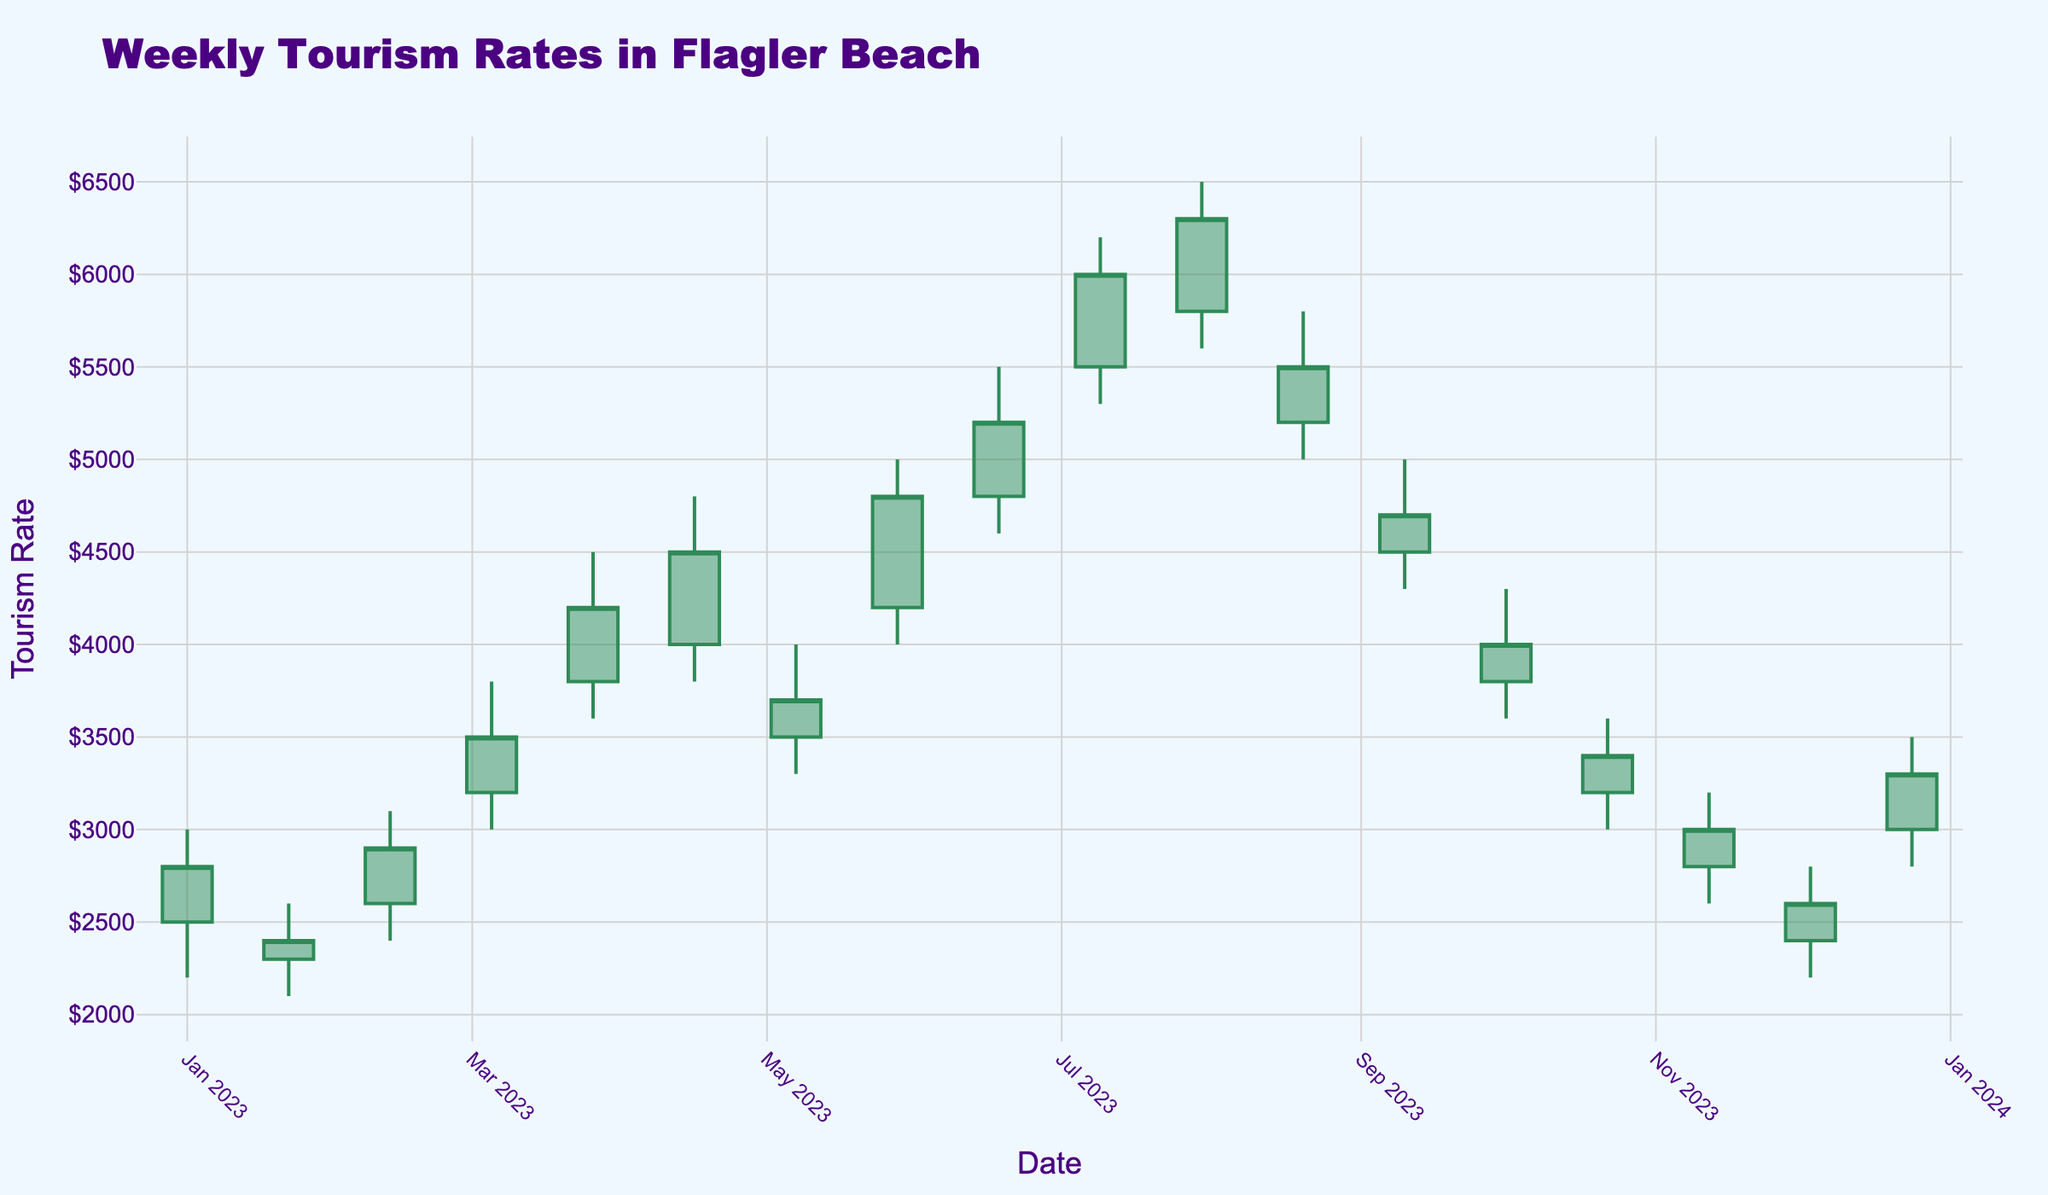What is the title of the chart? The title is usually located at the top of the chart. For the given chart, the title states "Weekly Tourism Rates in Flagler Beach."
Answer: Weekly Tourism Rates in Flagler Beach Which week had the highest tourism rate close? To find the week with the highest tourism rate at close, look for the highest point on the 'Close' line in the chart. In this case, it is the week "Jul 30-Aug 5" with a close of 6300.
Answer: Jul 30-Aug 5 What is the color of the lines for increasing tourism rates? The lines for increasing tourism rates are represented in a color. Here, the color mentioned is SeaGreen.
Answer: SeaGreen During which week did the tourism rate hit the lowest low? To find the week with the lowest low, look for the minimum point on the 'Low' line in the chart. That week is "Jan 22-28" with a low of 2100.
Answer: Jan 22-28 What is the average closing rate for the months of March and April? Calculate the average by adding the closing rates for all weeks in these two months and dividing by the number of weeks. The closing rates for March (3500, 4200) and April (4500) sum to 12200. There are 3 weeks, so the average is 12200 / 3.
Answer: 4067 Which week had the greatest difference between the high and the low rate? Identify the week with the greatest difference between high and low by subtracting the 'Low' from the 'High' each week and noting the maximum difference. For "Jul 30-Aug 5", the difference is 6500 - 5600 = 900, the greatest difference.
Answer: Jul 30-Aug 5 How do the tourism rates compare between January and July? Compare the average rates for January and July. For January, the close values are 2800 and 2400, so the average is (2800+2400)/2 = 2600. For July, the close values are 6000 and 6300, so the average is (6000+6300)/2 = 6150.
Answer: July averages higher than January What is the trend in tourism rates from May to July? Observe the 'Close' values from the beginning of May to the end of July. The values increase from 3700 at the start of May to 6300 by early August, indicating an upward trend.
Answer: Upward trend Which week had a close value that was also its high value? Find the week where the close is equal to the high value by comparing each week's close and high rates. For "Feb 12-18", the close value of 2900 matches the high value of 3100.
Answer: Feb 12-18 